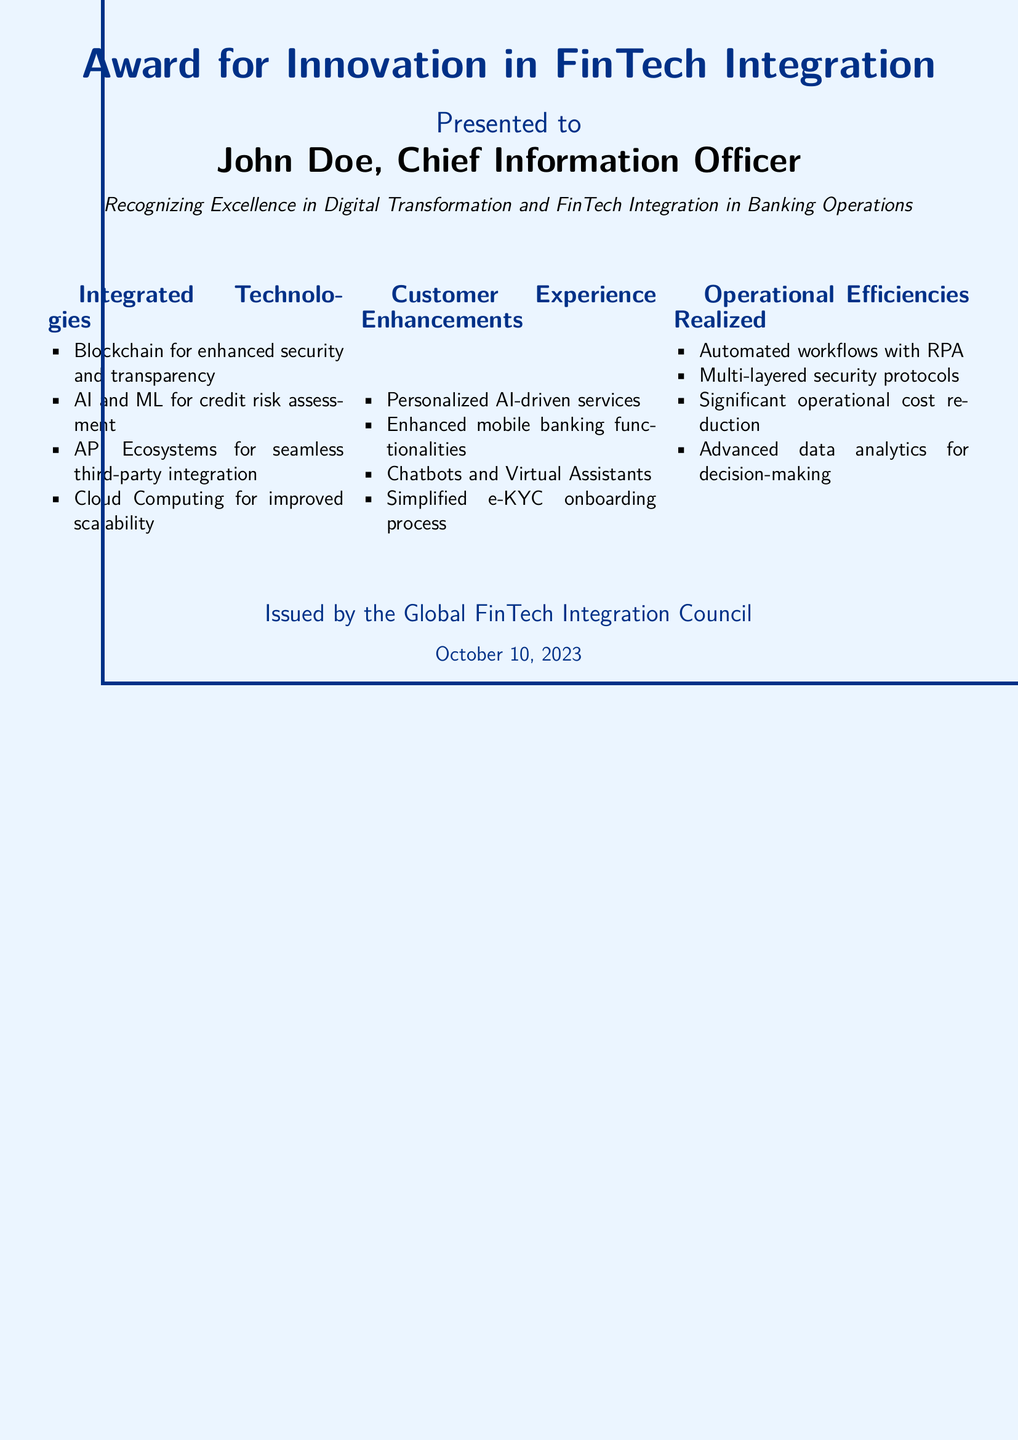What is the title of the award? The title of the award, as stated at the top of the document, is "Award for Innovation in FinTech Integration."
Answer: Award for Innovation in FinTech Integration Who is the recipient of the award? The document lists John Doe as the recipient.
Answer: John Doe What is the role of the recipient? The role specified for the recipient in the document is Chief Information Officer.
Answer: Chief Information Officer What organization issued the certificate? The document states it was issued by the Global FinTech Integration Council.
Answer: Global FinTech Integration Council On what date was the award issued? The date provided in the document for the award issuance is October 10, 2023.
Answer: October 10, 2023 Name one integrated technology mentioned in the document. The document lists several integrated technologies; one of them is Blockchain.
Answer: Blockchain What is one customer experience enhancement highlighted in the certificate? Among the enhancements, the document mentions personalized AI-driven services.
Answer: Personalized AI-driven services What operational efficiency is realized through RPA? The document states that automated workflows result in operational efficiencies through RPA.
Answer: Automated workflows with RPA How many sections are included in the document's breakdown of innovations? The document presents three distinct sections related to innovations: Integrated Technologies, Customer Experience Enhancements, and Operational Efficiencies Realized.
Answer: Three 